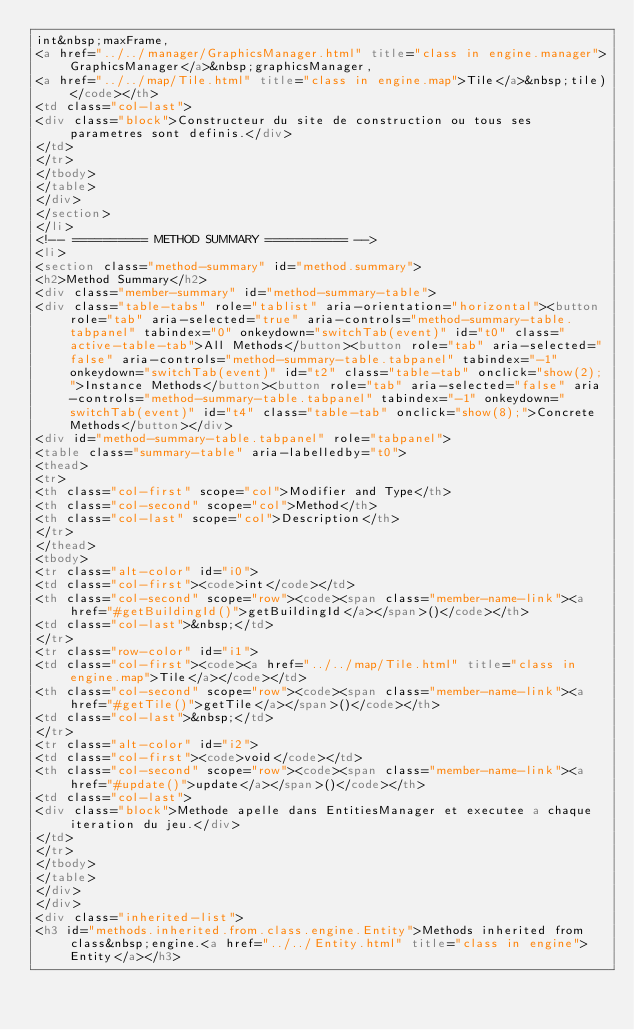Convert code to text. <code><loc_0><loc_0><loc_500><loc_500><_HTML_>int&nbsp;maxFrame,
<a href="../../manager/GraphicsManager.html" title="class in engine.manager">GraphicsManager</a>&nbsp;graphicsManager,
<a href="../../map/Tile.html" title="class in engine.map">Tile</a>&nbsp;tile)</code></th>
<td class="col-last">
<div class="block">Constructeur du site de construction ou tous ses parametres sont definis.</div>
</td>
</tr>
</tbody>
</table>
</div>
</section>
</li>
<!-- ========== METHOD SUMMARY =========== -->
<li>
<section class="method-summary" id="method.summary">
<h2>Method Summary</h2>
<div class="member-summary" id="method-summary-table">
<div class="table-tabs" role="tablist" aria-orientation="horizontal"><button role="tab" aria-selected="true" aria-controls="method-summary-table.tabpanel" tabindex="0" onkeydown="switchTab(event)" id="t0" class="active-table-tab">All Methods</button><button role="tab" aria-selected="false" aria-controls="method-summary-table.tabpanel" tabindex="-1" onkeydown="switchTab(event)" id="t2" class="table-tab" onclick="show(2);">Instance Methods</button><button role="tab" aria-selected="false" aria-controls="method-summary-table.tabpanel" tabindex="-1" onkeydown="switchTab(event)" id="t4" class="table-tab" onclick="show(8);">Concrete Methods</button></div>
<div id="method-summary-table.tabpanel" role="tabpanel">
<table class="summary-table" aria-labelledby="t0">
<thead>
<tr>
<th class="col-first" scope="col">Modifier and Type</th>
<th class="col-second" scope="col">Method</th>
<th class="col-last" scope="col">Description</th>
</tr>
</thead>
<tbody>
<tr class="alt-color" id="i0">
<td class="col-first"><code>int</code></td>
<th class="col-second" scope="row"><code><span class="member-name-link"><a href="#getBuildingId()">getBuildingId</a></span>()</code></th>
<td class="col-last">&nbsp;</td>
</tr>
<tr class="row-color" id="i1">
<td class="col-first"><code><a href="../../map/Tile.html" title="class in engine.map">Tile</a></code></td>
<th class="col-second" scope="row"><code><span class="member-name-link"><a href="#getTile()">getTile</a></span>()</code></th>
<td class="col-last">&nbsp;</td>
</tr>
<tr class="alt-color" id="i2">
<td class="col-first"><code>void</code></td>
<th class="col-second" scope="row"><code><span class="member-name-link"><a href="#update()">update</a></span>()</code></th>
<td class="col-last">
<div class="block">Methode apelle dans EntitiesManager et executee a chaque iteration du jeu.</div>
</td>
</tr>
</tbody>
</table>
</div>
</div>
<div class="inherited-list">
<h3 id="methods.inherited.from.class.engine.Entity">Methods inherited from class&nbsp;engine.<a href="../../Entity.html" title="class in engine">Entity</a></h3></code> 